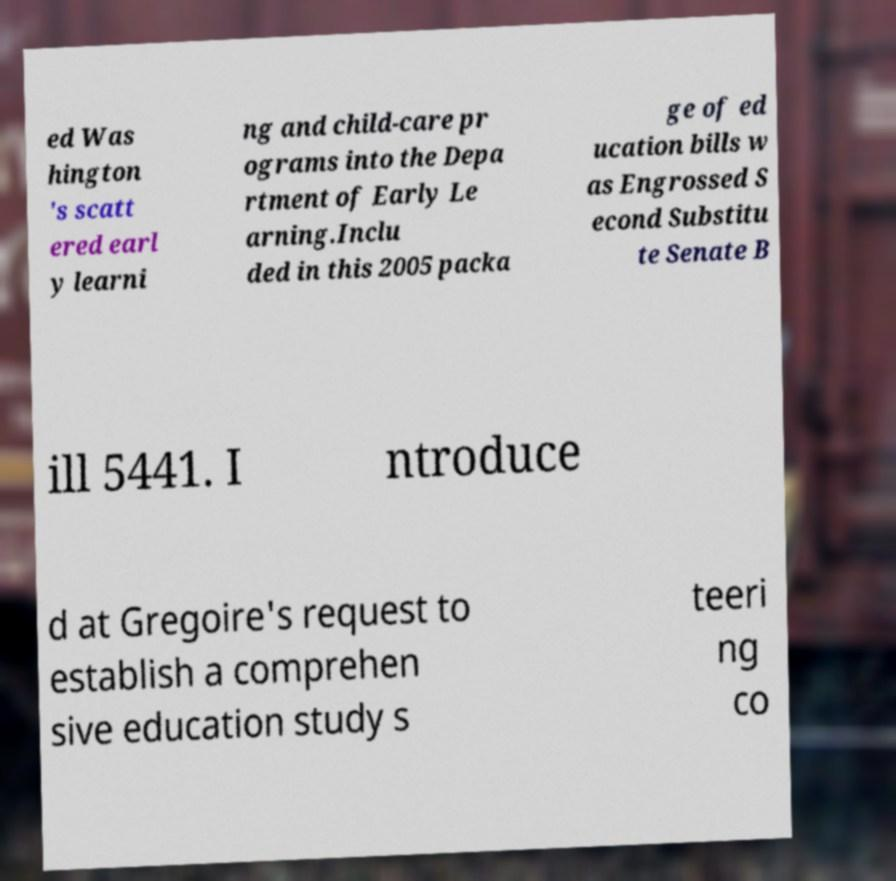Could you assist in decoding the text presented in this image and type it out clearly? ed Was hington 's scatt ered earl y learni ng and child-care pr ograms into the Depa rtment of Early Le arning.Inclu ded in this 2005 packa ge of ed ucation bills w as Engrossed S econd Substitu te Senate B ill 5441. I ntroduce d at Gregoire's request to establish a comprehen sive education study s teeri ng co 